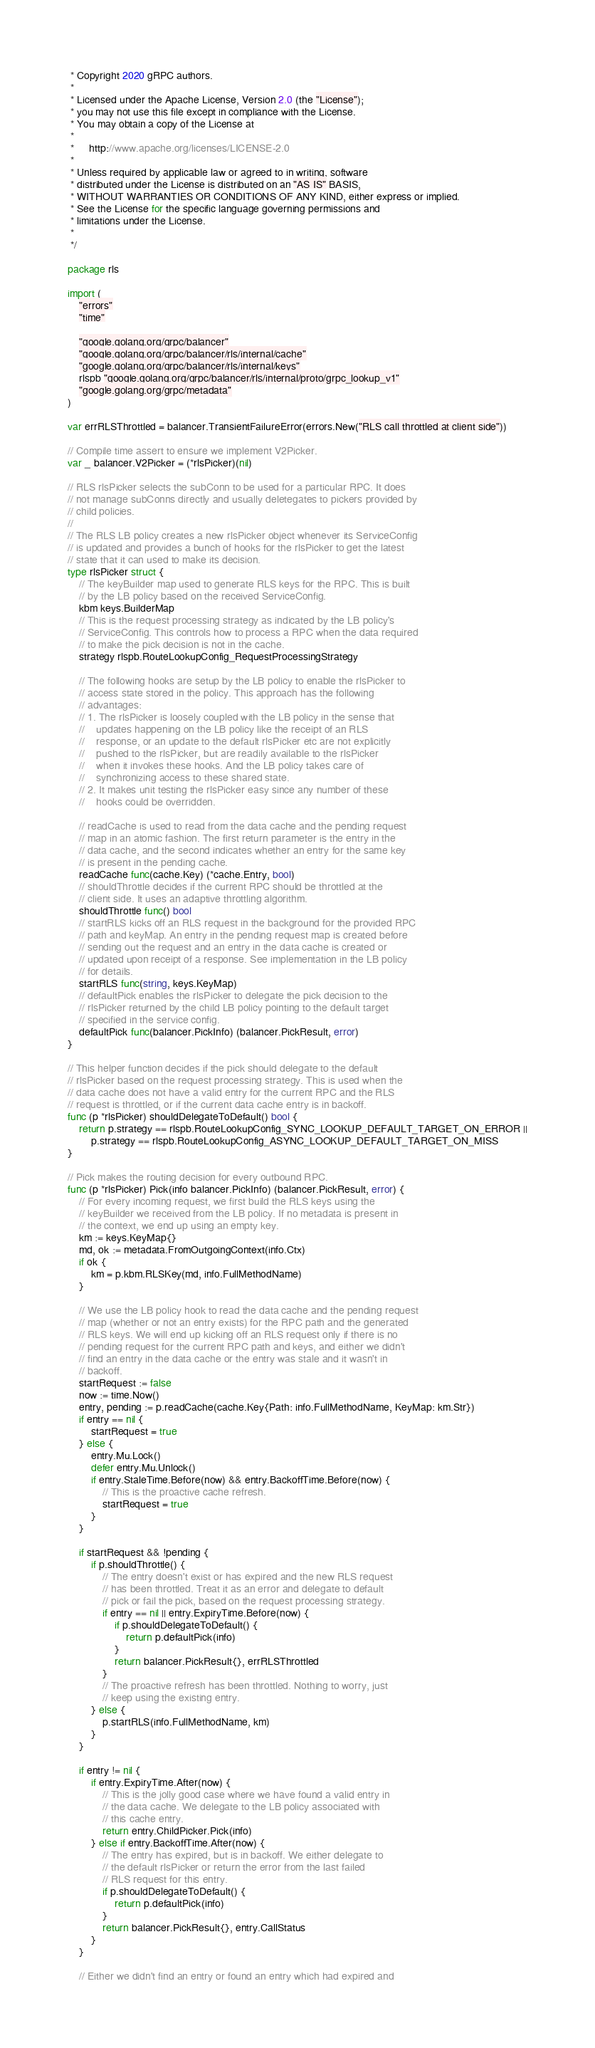<code> <loc_0><loc_0><loc_500><loc_500><_Go_> * Copyright 2020 gRPC authors.
 *
 * Licensed under the Apache License, Version 2.0 (the "License");
 * you may not use this file except in compliance with the License.
 * You may obtain a copy of the License at
 *
 *     http://www.apache.org/licenses/LICENSE-2.0
 *
 * Unless required by applicable law or agreed to in writing, software
 * distributed under the License is distributed on an "AS IS" BASIS,
 * WITHOUT WARRANTIES OR CONDITIONS OF ANY KIND, either express or implied.
 * See the License for the specific language governing permissions and
 * limitations under the License.
 *
 */

package rls

import (
	"errors"
	"time"

	"google.golang.org/grpc/balancer"
	"google.golang.org/grpc/balancer/rls/internal/cache"
	"google.golang.org/grpc/balancer/rls/internal/keys"
	rlspb "google.golang.org/grpc/balancer/rls/internal/proto/grpc_lookup_v1"
	"google.golang.org/grpc/metadata"
)

var errRLSThrottled = balancer.TransientFailureError(errors.New("RLS call throttled at client side"))

// Compile time assert to ensure we implement V2Picker.
var _ balancer.V2Picker = (*rlsPicker)(nil)

// RLS rlsPicker selects the subConn to be used for a particular RPC. It does
// not manage subConns directly and usually deletegates to pickers provided by
// child policies.
//
// The RLS LB policy creates a new rlsPicker object whenever its ServiceConfig
// is updated and provides a bunch of hooks for the rlsPicker to get the latest
// state that it can used to make its decision.
type rlsPicker struct {
	// The keyBuilder map used to generate RLS keys for the RPC. This is built
	// by the LB policy based on the received ServiceConfig.
	kbm keys.BuilderMap
	// This is the request processing strategy as indicated by the LB policy's
	// ServiceConfig. This controls how to process a RPC when the data required
	// to make the pick decision is not in the cache.
	strategy rlspb.RouteLookupConfig_RequestProcessingStrategy

	// The following hooks are setup by the LB policy to enable the rlsPicker to
	// access state stored in the policy. This approach has the following
	// advantages:
	// 1. The rlsPicker is loosely coupled with the LB policy in the sense that
	//    updates happening on the LB policy like the receipt of an RLS
	//    response, or an update to the default rlsPicker etc are not explicitly
	//    pushed to the rlsPicker, but are readily available to the rlsPicker
	//    when it invokes these hooks. And the LB policy takes care of
	//    synchronizing access to these shared state.
	// 2. It makes unit testing the rlsPicker easy since any number of these
	//    hooks could be overridden.

	// readCache is used to read from the data cache and the pending request
	// map in an atomic fashion. The first return parameter is the entry in the
	// data cache, and the second indicates whether an entry for the same key
	// is present in the pending cache.
	readCache func(cache.Key) (*cache.Entry, bool)
	// shouldThrottle decides if the current RPC should be throttled at the
	// client side. It uses an adaptive throttling algorithm.
	shouldThrottle func() bool
	// startRLS kicks off an RLS request in the background for the provided RPC
	// path and keyMap. An entry in the pending request map is created before
	// sending out the request and an entry in the data cache is created or
	// updated upon receipt of a response. See implementation in the LB policy
	// for details.
	startRLS func(string, keys.KeyMap)
	// defaultPick enables the rlsPicker to delegate the pick decision to the
	// rlsPicker returned by the child LB policy pointing to the default target
	// specified in the service config.
	defaultPick func(balancer.PickInfo) (balancer.PickResult, error)
}

// This helper function decides if the pick should delegate to the default
// rlsPicker based on the request processing strategy. This is used when the
// data cache does not have a valid entry for the current RPC and the RLS
// request is throttled, or if the current data cache entry is in backoff.
func (p *rlsPicker) shouldDelegateToDefault() bool {
	return p.strategy == rlspb.RouteLookupConfig_SYNC_LOOKUP_DEFAULT_TARGET_ON_ERROR ||
		p.strategy == rlspb.RouteLookupConfig_ASYNC_LOOKUP_DEFAULT_TARGET_ON_MISS
}

// Pick makes the routing decision for every outbound RPC.
func (p *rlsPicker) Pick(info balancer.PickInfo) (balancer.PickResult, error) {
	// For every incoming request, we first build the RLS keys using the
	// keyBuilder we received from the LB policy. If no metadata is present in
	// the context, we end up using an empty key.
	km := keys.KeyMap{}
	md, ok := metadata.FromOutgoingContext(info.Ctx)
	if ok {
		km = p.kbm.RLSKey(md, info.FullMethodName)
	}

	// We use the LB policy hook to read the data cache and the pending request
	// map (whether or not an entry exists) for the RPC path and the generated
	// RLS keys. We will end up kicking off an RLS request only if there is no
	// pending request for the current RPC path and keys, and either we didn't
	// find an entry in the data cache or the entry was stale and it wasn't in
	// backoff.
	startRequest := false
	now := time.Now()
	entry, pending := p.readCache(cache.Key{Path: info.FullMethodName, KeyMap: km.Str})
	if entry == nil {
		startRequest = true
	} else {
		entry.Mu.Lock()
		defer entry.Mu.Unlock()
		if entry.StaleTime.Before(now) && entry.BackoffTime.Before(now) {
			// This is the proactive cache refresh.
			startRequest = true
		}
	}

	if startRequest && !pending {
		if p.shouldThrottle() {
			// The entry doesn't exist or has expired and the new RLS request
			// has been throttled. Treat it as an error and delegate to default
			// pick or fail the pick, based on the request processing strategy.
			if entry == nil || entry.ExpiryTime.Before(now) {
				if p.shouldDelegateToDefault() {
					return p.defaultPick(info)
				}
				return balancer.PickResult{}, errRLSThrottled
			}
			// The proactive refresh has been throttled. Nothing to worry, just
			// keep using the existing entry.
		} else {
			p.startRLS(info.FullMethodName, km)
		}
	}

	if entry != nil {
		if entry.ExpiryTime.After(now) {
			// This is the jolly good case where we have found a valid entry in
			// the data cache. We delegate to the LB policy associated with
			// this cache entry.
			return entry.ChildPicker.Pick(info)
		} else if entry.BackoffTime.After(now) {
			// The entry has expired, but is in backoff. We either delegate to
			// the default rlsPicker or return the error from the last failed
			// RLS request for this entry.
			if p.shouldDelegateToDefault() {
				return p.defaultPick(info)
			}
			return balancer.PickResult{}, entry.CallStatus
		}
	}

	// Either we didn't find an entry or found an entry which had expired and</code> 